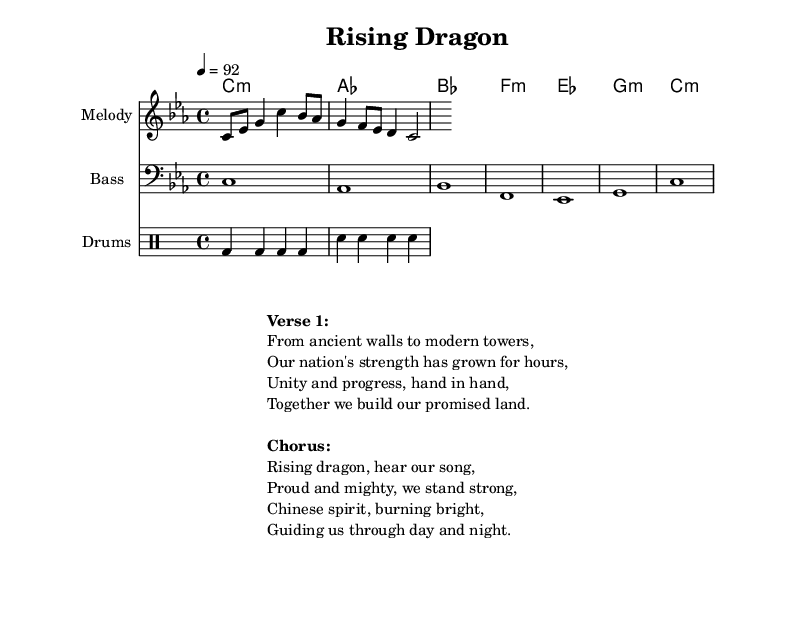What is the key signature of this music? The key signature is C minor, which is indicated by three flats. This is derived from the "global" section of the code where \key c \minor is specified.
Answer: C minor What is the time signature of this music? The time signature is 4/4, which is commonly used and allows for four beats in each measure. This is evident from the \time 4/4 directive in the global section.
Answer: 4/4 What is the tempo marking for this piece? The tempo marking is 92 beats per minute, identified by the \tempo 4 = 92 notation. This indicates how fast the music should be played.
Answer: 92 How many measures are in the melody? The melody consists of four measures. This was determined by counting the number of distinct groups separated by vertical lines in the melody section.
Answer: 4 What type of music is this? This music is Hip Hop, with a focus on patriotic themes as evident in the verses discussed alongside national pride and achievements. It is indicated in the overall theme and style.
Answer: Hip Hop What is the main theme of the chorus? The main theme of the chorus is national pride, focusing on being proud and strong as a country, as expressed in the lyrics provided under the Chorus section.
Answer: National pride How does the drum pattern contribute to the hip-hop feel? The drum pattern features a standard four-on-the-floor beat which is characteristic of hip-hop, emphasizing the rhythm and driving nature typical in this genre. This is evident from the consistent bass and snare hits.
Answer: Driving rhythm 